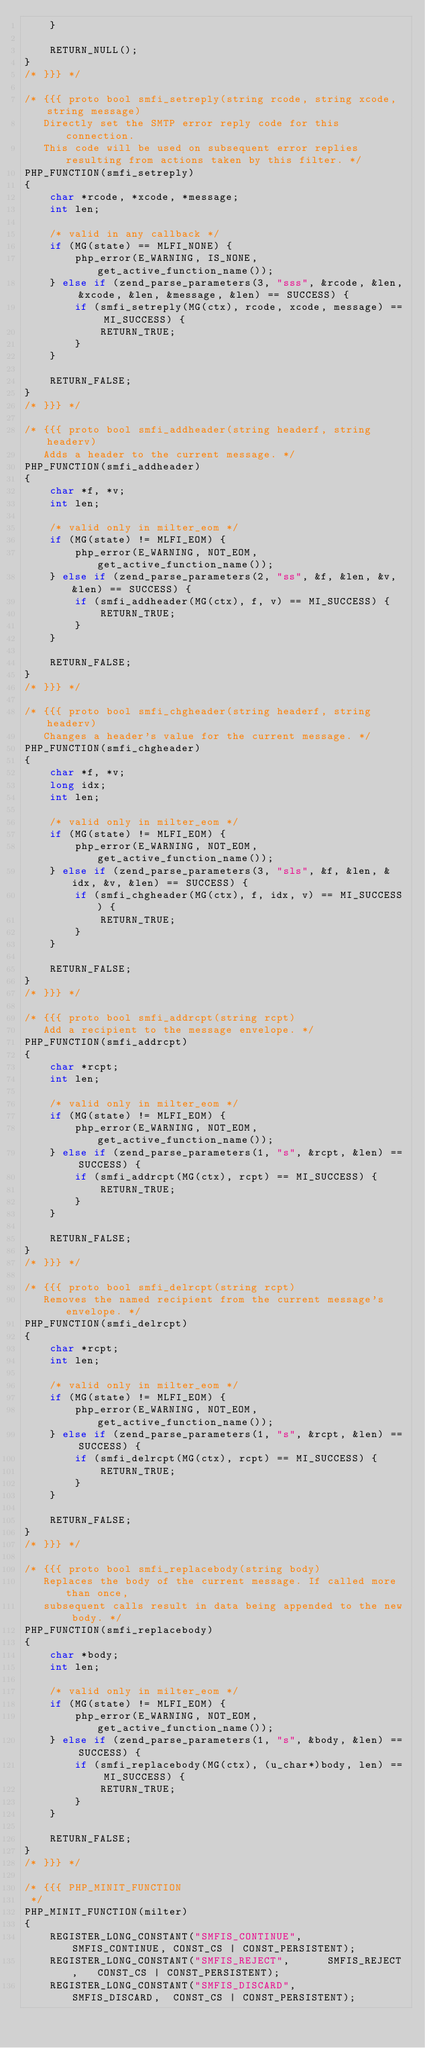Convert code to text. <code><loc_0><loc_0><loc_500><loc_500><_C_>	}

	RETURN_NULL();
}
/* }}} */

/* {{{ proto bool smfi_setreply(string rcode, string xcode, string message)
   Directly set the SMTP error reply code for this connection.
   This code will be used on subsequent error replies resulting from actions taken by this filter. */
PHP_FUNCTION(smfi_setreply)
{
	char *rcode, *xcode, *message;
	int len;

	/* valid in any callback */
	if (MG(state) == MLFI_NONE) {
		php_error(E_WARNING, IS_NONE, get_active_function_name());
	} else if (zend_parse_parameters(3, "sss", &rcode, &len, &xcode, &len, &message, &len) == SUCCESS) {
		if (smfi_setreply(MG(ctx), rcode, xcode, message) == MI_SUCCESS) {
			RETURN_TRUE;
		}
	}

	RETURN_FALSE;
}
/* }}} */

/* {{{ proto bool smfi_addheader(string headerf, string headerv)
   Adds a header to the current message. */
PHP_FUNCTION(smfi_addheader)
{
	char *f, *v;
	int len;

	/* valid only in milter_eom */
	if (MG(state) != MLFI_EOM) {
		php_error(E_WARNING, NOT_EOM, get_active_function_name());
	} else if (zend_parse_parameters(2, "ss", &f, &len, &v, &len) == SUCCESS) {
		if (smfi_addheader(MG(ctx), f, v) == MI_SUCCESS) {
			RETURN_TRUE;
		}
	}

	RETURN_FALSE;
}
/* }}} */

/* {{{ proto bool smfi_chgheader(string headerf, string headerv)
   Changes a header's value for the current message. */
PHP_FUNCTION(smfi_chgheader)
{
	char *f, *v;
	long idx;
	int len;

	/* valid only in milter_eom */
	if (MG(state) != MLFI_EOM) {
		php_error(E_WARNING, NOT_EOM, get_active_function_name());
	} else if (zend_parse_parameters(3, "sls", &f, &len, &idx, &v, &len) == SUCCESS) {
		if (smfi_chgheader(MG(ctx), f, idx, v) == MI_SUCCESS) {
			RETURN_TRUE;
		}
	}

	RETURN_FALSE;
}
/* }}} */

/* {{{ proto bool smfi_addrcpt(string rcpt)
   Add a recipient to the message envelope. */
PHP_FUNCTION(smfi_addrcpt)
{
	char *rcpt;
	int len;

	/* valid only in milter_eom */
	if (MG(state) != MLFI_EOM) {
		php_error(E_WARNING, NOT_EOM, get_active_function_name());
	} else if (zend_parse_parameters(1, "s", &rcpt, &len) == SUCCESS) {
		if (smfi_addrcpt(MG(ctx), rcpt) == MI_SUCCESS) {
			RETURN_TRUE;
		}
	}

	RETURN_FALSE;
}
/* }}} */

/* {{{ proto bool smfi_delrcpt(string rcpt)
   Removes the named recipient from the current message's envelope. */
PHP_FUNCTION(smfi_delrcpt)
{
	char *rcpt;
	int len;

	/* valid only in milter_eom */
	if (MG(state) != MLFI_EOM) {
		php_error(E_WARNING, NOT_EOM, get_active_function_name());
	} else if (zend_parse_parameters(1, "s", &rcpt, &len) == SUCCESS) {
		if (smfi_delrcpt(MG(ctx), rcpt) == MI_SUCCESS) {
			RETURN_TRUE;
		}
	}

	RETURN_FALSE;
}
/* }}} */

/* {{{ proto bool smfi_replacebody(string body)
   Replaces the body of the current message. If called more than once,
   subsequent calls result in data being appended to the new body. */
PHP_FUNCTION(smfi_replacebody)
{
	char *body;
	int len;

	/* valid only in milter_eom */
	if (MG(state) != MLFI_EOM) {
		php_error(E_WARNING, NOT_EOM, get_active_function_name());
	} else if (zend_parse_parameters(1, "s", &body, &len) == SUCCESS) {
		if (smfi_replacebody(MG(ctx), (u_char*)body, len) == MI_SUCCESS) {
			RETURN_TRUE;
		}
	}

	RETURN_FALSE;
}
/* }}} */

/* {{{ PHP_MINIT_FUNCTION
 */
PHP_MINIT_FUNCTION(milter)
{
	REGISTER_LONG_CONSTANT("SMFIS_CONTINUE",	SMFIS_CONTINUE,	CONST_CS | CONST_PERSISTENT);
	REGISTER_LONG_CONSTANT("SMFIS_REJECT",		SMFIS_REJECT,	CONST_CS | CONST_PERSISTENT);
	REGISTER_LONG_CONSTANT("SMFIS_DISCARD",		SMFIS_DISCARD,	CONST_CS | CONST_PERSISTENT);</code> 